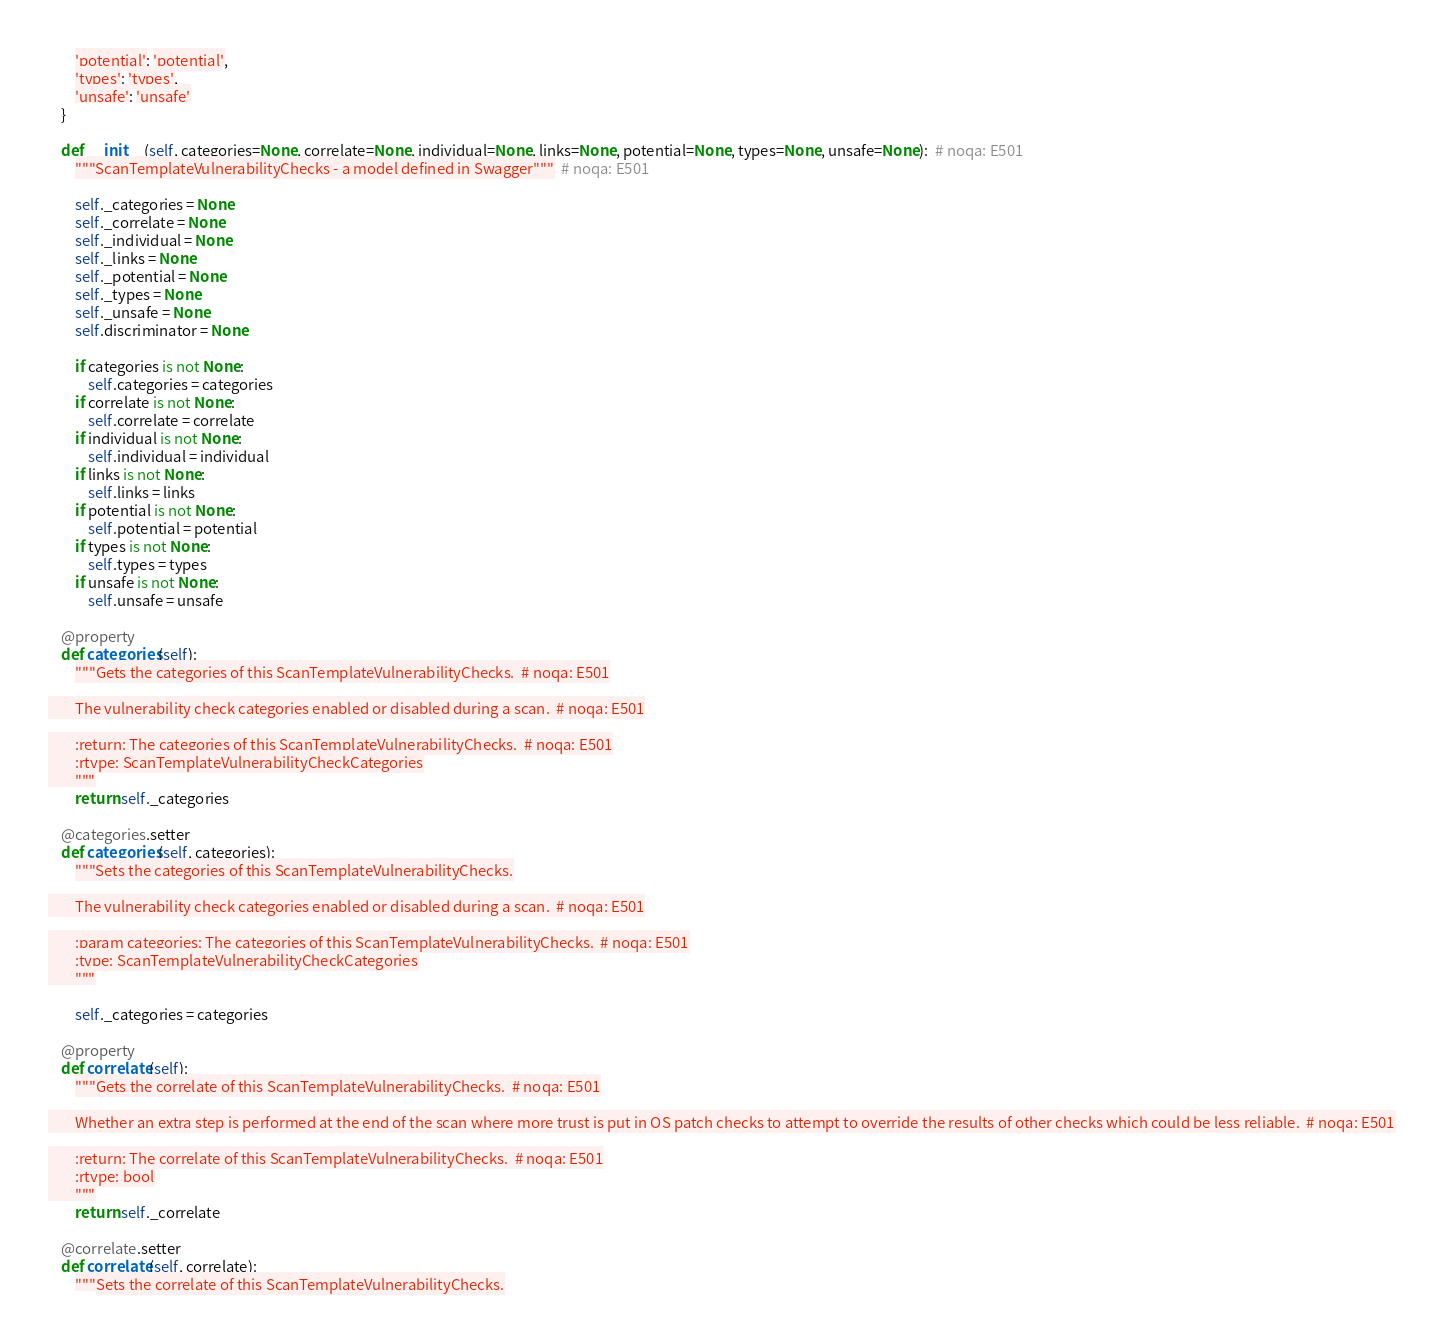<code> <loc_0><loc_0><loc_500><loc_500><_Python_>        'potential': 'potential',
        'types': 'types',
        'unsafe': 'unsafe'
    }

    def __init__(self, categories=None, correlate=None, individual=None, links=None, potential=None, types=None, unsafe=None):  # noqa: E501
        """ScanTemplateVulnerabilityChecks - a model defined in Swagger"""  # noqa: E501

        self._categories = None
        self._correlate = None
        self._individual = None
        self._links = None
        self._potential = None
        self._types = None
        self._unsafe = None
        self.discriminator = None

        if categories is not None:
            self.categories = categories
        if correlate is not None:
            self.correlate = correlate
        if individual is not None:
            self.individual = individual
        if links is not None:
            self.links = links
        if potential is not None:
            self.potential = potential
        if types is not None:
            self.types = types
        if unsafe is not None:
            self.unsafe = unsafe

    @property
    def categories(self):
        """Gets the categories of this ScanTemplateVulnerabilityChecks.  # noqa: E501

        The vulnerability check categories enabled or disabled during a scan.  # noqa: E501

        :return: The categories of this ScanTemplateVulnerabilityChecks.  # noqa: E501
        :rtype: ScanTemplateVulnerabilityCheckCategories
        """
        return self._categories

    @categories.setter
    def categories(self, categories):
        """Sets the categories of this ScanTemplateVulnerabilityChecks.

        The vulnerability check categories enabled or disabled during a scan.  # noqa: E501

        :param categories: The categories of this ScanTemplateVulnerabilityChecks.  # noqa: E501
        :type: ScanTemplateVulnerabilityCheckCategories
        """

        self._categories = categories

    @property
    def correlate(self):
        """Gets the correlate of this ScanTemplateVulnerabilityChecks.  # noqa: E501

        Whether an extra step is performed at the end of the scan where more trust is put in OS patch checks to attempt to override the results of other checks which could be less reliable.  # noqa: E501

        :return: The correlate of this ScanTemplateVulnerabilityChecks.  # noqa: E501
        :rtype: bool
        """
        return self._correlate

    @correlate.setter
    def correlate(self, correlate):
        """Sets the correlate of this ScanTemplateVulnerabilityChecks.
</code> 